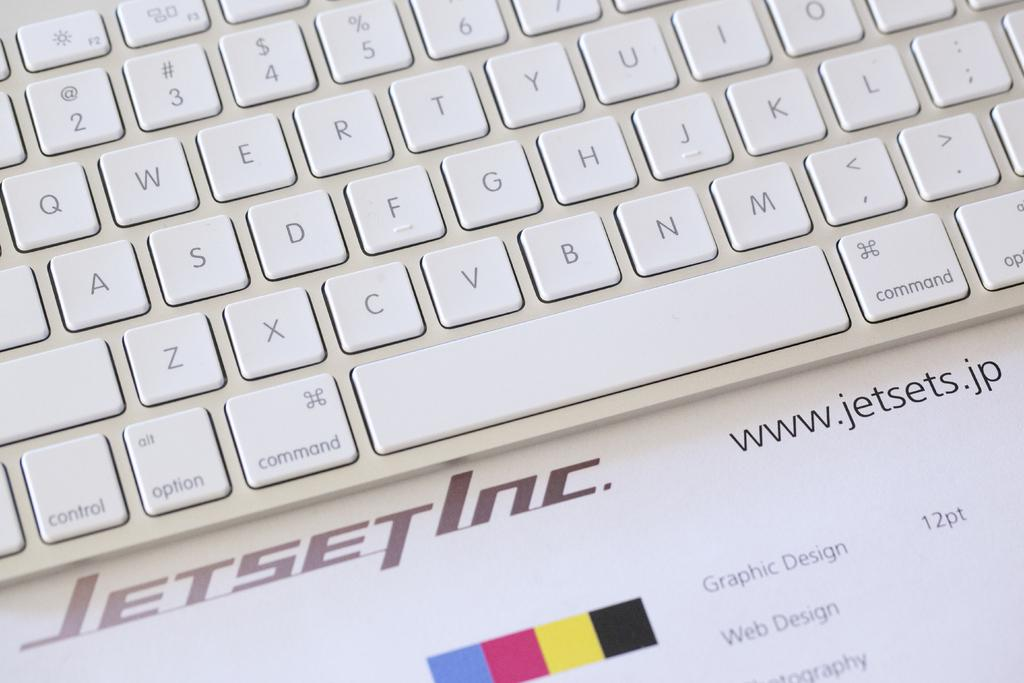<image>
Write a terse but informative summary of the picture. a white keyboard is sitting on an ad for jetset inc 